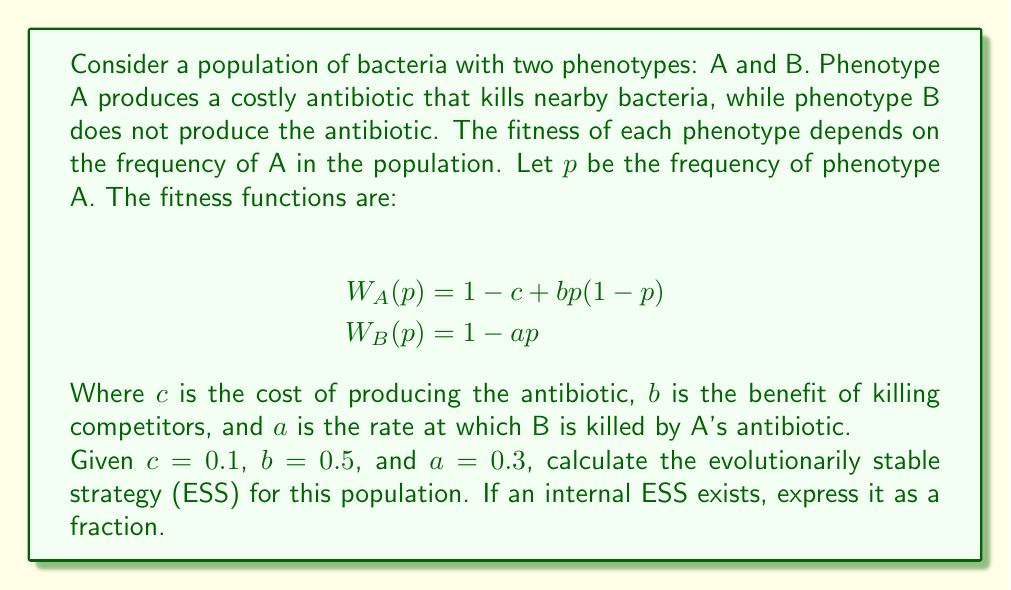Show me your answer to this math problem. To solve this problem, we'll follow these steps:

1. Find the conditions for an internal ESS
2. Calculate the ESS if it exists
3. Check if it's a valid ESS

Step 1: Conditions for an internal ESS

For an internal ESS to exist, the fitness of A and B must be equal when the population is at equilibrium. This occurs when:

$$ W_A(p^*) = W_B(p^*) $$

Where $p^*$ is the ESS frequency of phenotype A.

Step 2: Calculating the ESS

Let's set the fitness functions equal to each other:

$$ 1 - c + bp^*(1-p^*) = 1 - ap^* $$

Simplifying:

$$ -c + bp^* - b(p^*)^2 = -ap^* $$

Rearranging terms:

$$ b(p^*)^2 + (a-b)p^* + c = 0 $$

This is a quadratic equation in the form $ax^2 + bx + c = 0$. We can solve it using the quadratic formula:

$$ p^* = \frac{-(a-b) \pm \sqrt{(a-b)^2 - 4bc}}{2b} $$

Substituting the given values:

$$ p^* = \frac{-(0.3-0.5) \pm \sqrt{(0.3-0.5)^2 - 4(0.5)(0.1)}}{2(0.5)} $$

$$ p^* = \frac{0.2 \pm \sqrt{0.04 - 0.2}}{1} $$

$$ p^* = \frac{0.2 \pm \sqrt{-0.16}}{1} $$

Since the discriminant is negative, there are no real solutions. This means there is no internal ESS.

Step 3: Checking for boundary ESSs

Since there's no internal ESS, we need to check the boundary conditions:

1. If $p = 0$ (all B), is A invasive?
   $W_A(0) = 1 - c = 0.9$
   $W_B(0) = 1$
   Since $W_B(0) > W_A(0)$, A cannot invade.

2. If $p = 1$ (all A), is B invasive?
   $W_A(1) = 1 - c = 0.9$
   $W_B(1) = 1 - a = 0.7$
   Since $W_A(1) > W_B(1)$, B cannot invade.

Therefore, $p^* = 1$ (all A) is the ESS for this population.
Answer: The evolutionarily stable strategy (ESS) for this population is $p^* = 1$, meaning the entire population will adopt phenotype A (antibiotic producers). 